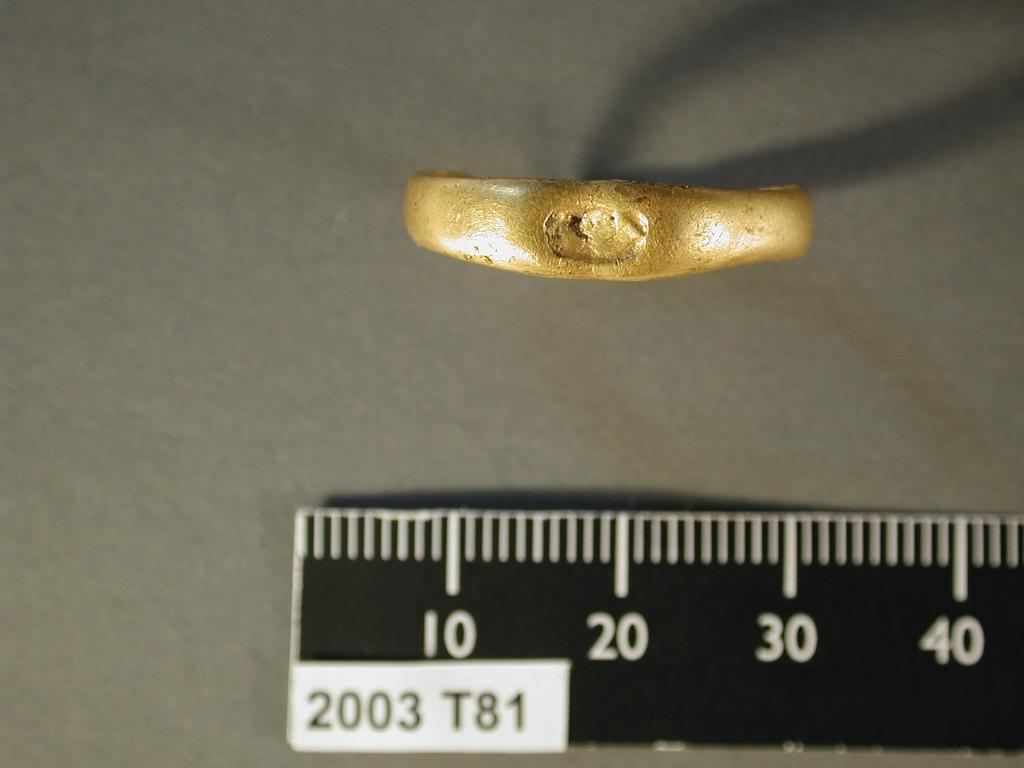<image>
Offer a succinct explanation of the picture presented. a ruler that has 10 to 40 on it 